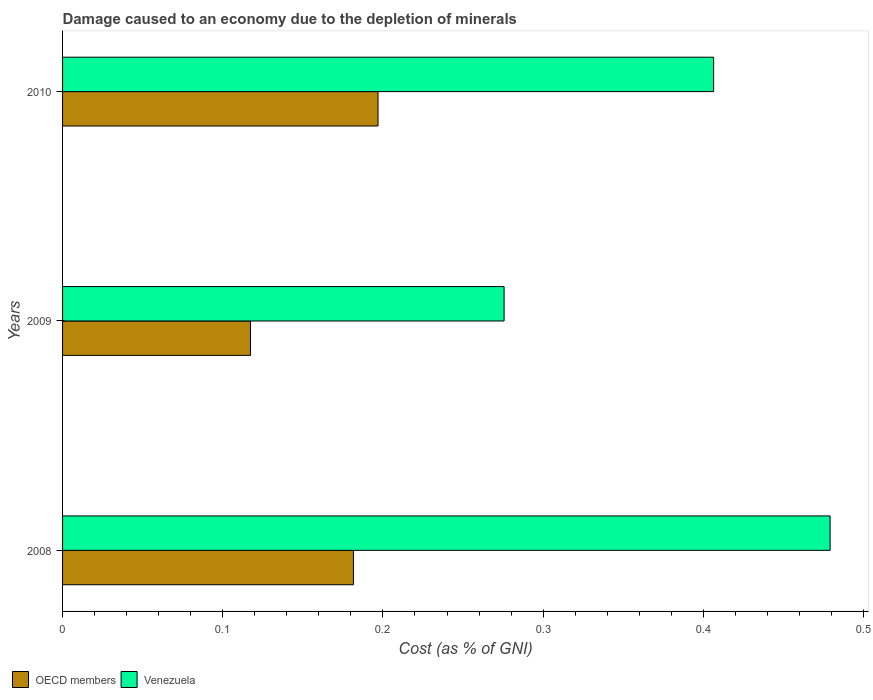How many different coloured bars are there?
Your answer should be compact. 2. Are the number of bars per tick equal to the number of legend labels?
Your response must be concise. Yes. In how many cases, is the number of bars for a given year not equal to the number of legend labels?
Your response must be concise. 0. What is the cost of damage caused due to the depletion of minerals in OECD members in 2008?
Make the answer very short. 0.18. Across all years, what is the maximum cost of damage caused due to the depletion of minerals in Venezuela?
Your answer should be compact. 0.48. Across all years, what is the minimum cost of damage caused due to the depletion of minerals in Venezuela?
Give a very brief answer. 0.28. What is the total cost of damage caused due to the depletion of minerals in OECD members in the graph?
Make the answer very short. 0.5. What is the difference between the cost of damage caused due to the depletion of minerals in Venezuela in 2008 and that in 2010?
Your response must be concise. 0.07. What is the difference between the cost of damage caused due to the depletion of minerals in Venezuela in 2010 and the cost of damage caused due to the depletion of minerals in OECD members in 2008?
Your answer should be very brief. 0.22. What is the average cost of damage caused due to the depletion of minerals in OECD members per year?
Offer a very short reply. 0.17. In the year 2009, what is the difference between the cost of damage caused due to the depletion of minerals in Venezuela and cost of damage caused due to the depletion of minerals in OECD members?
Offer a very short reply. 0.16. In how many years, is the cost of damage caused due to the depletion of minerals in OECD members greater than 0.12000000000000001 %?
Your answer should be compact. 2. What is the ratio of the cost of damage caused due to the depletion of minerals in OECD members in 2009 to that in 2010?
Your answer should be compact. 0.6. Is the difference between the cost of damage caused due to the depletion of minerals in Venezuela in 2008 and 2009 greater than the difference between the cost of damage caused due to the depletion of minerals in OECD members in 2008 and 2009?
Offer a terse response. Yes. What is the difference between the highest and the second highest cost of damage caused due to the depletion of minerals in OECD members?
Make the answer very short. 0.02. What is the difference between the highest and the lowest cost of damage caused due to the depletion of minerals in Venezuela?
Provide a succinct answer. 0.2. Is the sum of the cost of damage caused due to the depletion of minerals in Venezuela in 2008 and 2009 greater than the maximum cost of damage caused due to the depletion of minerals in OECD members across all years?
Ensure brevity in your answer.  Yes. What does the 1st bar from the top in 2010 represents?
Provide a short and direct response. Venezuela. What does the 2nd bar from the bottom in 2008 represents?
Give a very brief answer. Venezuela. Are all the bars in the graph horizontal?
Provide a succinct answer. Yes. How many years are there in the graph?
Ensure brevity in your answer.  3. Are the values on the major ticks of X-axis written in scientific E-notation?
Offer a very short reply. No. Does the graph contain grids?
Give a very brief answer. No. Where does the legend appear in the graph?
Ensure brevity in your answer.  Bottom left. What is the title of the graph?
Your response must be concise. Damage caused to an economy due to the depletion of minerals. What is the label or title of the X-axis?
Your answer should be very brief. Cost (as % of GNI). What is the label or title of the Y-axis?
Make the answer very short. Years. What is the Cost (as % of GNI) of OECD members in 2008?
Keep it short and to the point. 0.18. What is the Cost (as % of GNI) in Venezuela in 2008?
Provide a succinct answer. 0.48. What is the Cost (as % of GNI) in OECD members in 2009?
Offer a terse response. 0.12. What is the Cost (as % of GNI) in Venezuela in 2009?
Offer a terse response. 0.28. What is the Cost (as % of GNI) of OECD members in 2010?
Your answer should be very brief. 0.2. What is the Cost (as % of GNI) in Venezuela in 2010?
Offer a very short reply. 0.41. Across all years, what is the maximum Cost (as % of GNI) in OECD members?
Offer a very short reply. 0.2. Across all years, what is the maximum Cost (as % of GNI) of Venezuela?
Keep it short and to the point. 0.48. Across all years, what is the minimum Cost (as % of GNI) in OECD members?
Offer a terse response. 0.12. Across all years, what is the minimum Cost (as % of GNI) of Venezuela?
Make the answer very short. 0.28. What is the total Cost (as % of GNI) of OECD members in the graph?
Your answer should be compact. 0.5. What is the total Cost (as % of GNI) of Venezuela in the graph?
Your answer should be compact. 1.16. What is the difference between the Cost (as % of GNI) of OECD members in 2008 and that in 2009?
Make the answer very short. 0.06. What is the difference between the Cost (as % of GNI) in Venezuela in 2008 and that in 2009?
Offer a terse response. 0.2. What is the difference between the Cost (as % of GNI) in OECD members in 2008 and that in 2010?
Give a very brief answer. -0.02. What is the difference between the Cost (as % of GNI) of Venezuela in 2008 and that in 2010?
Your answer should be compact. 0.07. What is the difference between the Cost (as % of GNI) of OECD members in 2009 and that in 2010?
Offer a terse response. -0.08. What is the difference between the Cost (as % of GNI) of Venezuela in 2009 and that in 2010?
Your answer should be compact. -0.13. What is the difference between the Cost (as % of GNI) of OECD members in 2008 and the Cost (as % of GNI) of Venezuela in 2009?
Offer a terse response. -0.09. What is the difference between the Cost (as % of GNI) of OECD members in 2008 and the Cost (as % of GNI) of Venezuela in 2010?
Keep it short and to the point. -0.22. What is the difference between the Cost (as % of GNI) in OECD members in 2009 and the Cost (as % of GNI) in Venezuela in 2010?
Make the answer very short. -0.29. What is the average Cost (as % of GNI) of OECD members per year?
Ensure brevity in your answer.  0.17. What is the average Cost (as % of GNI) in Venezuela per year?
Your answer should be very brief. 0.39. In the year 2008, what is the difference between the Cost (as % of GNI) of OECD members and Cost (as % of GNI) of Venezuela?
Provide a short and direct response. -0.3. In the year 2009, what is the difference between the Cost (as % of GNI) of OECD members and Cost (as % of GNI) of Venezuela?
Provide a short and direct response. -0.16. In the year 2010, what is the difference between the Cost (as % of GNI) in OECD members and Cost (as % of GNI) in Venezuela?
Provide a succinct answer. -0.21. What is the ratio of the Cost (as % of GNI) of OECD members in 2008 to that in 2009?
Keep it short and to the point. 1.55. What is the ratio of the Cost (as % of GNI) of Venezuela in 2008 to that in 2009?
Ensure brevity in your answer.  1.74. What is the ratio of the Cost (as % of GNI) in OECD members in 2008 to that in 2010?
Make the answer very short. 0.92. What is the ratio of the Cost (as % of GNI) of Venezuela in 2008 to that in 2010?
Keep it short and to the point. 1.18. What is the ratio of the Cost (as % of GNI) of OECD members in 2009 to that in 2010?
Your answer should be compact. 0.6. What is the ratio of the Cost (as % of GNI) in Venezuela in 2009 to that in 2010?
Keep it short and to the point. 0.68. What is the difference between the highest and the second highest Cost (as % of GNI) in OECD members?
Keep it short and to the point. 0.02. What is the difference between the highest and the second highest Cost (as % of GNI) in Venezuela?
Make the answer very short. 0.07. What is the difference between the highest and the lowest Cost (as % of GNI) of OECD members?
Provide a short and direct response. 0.08. What is the difference between the highest and the lowest Cost (as % of GNI) of Venezuela?
Offer a very short reply. 0.2. 